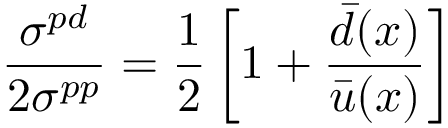Convert formula to latex. <formula><loc_0><loc_0><loc_500><loc_500>{ \frac { \sigma ^ { p d } } { 2 \sigma ^ { p p } } } = { \frac { 1 } { 2 } } \left [ 1 + { \frac { { \bar { d } } ( x ) } { { \bar { u } } ( x ) } } \right ]</formula> 